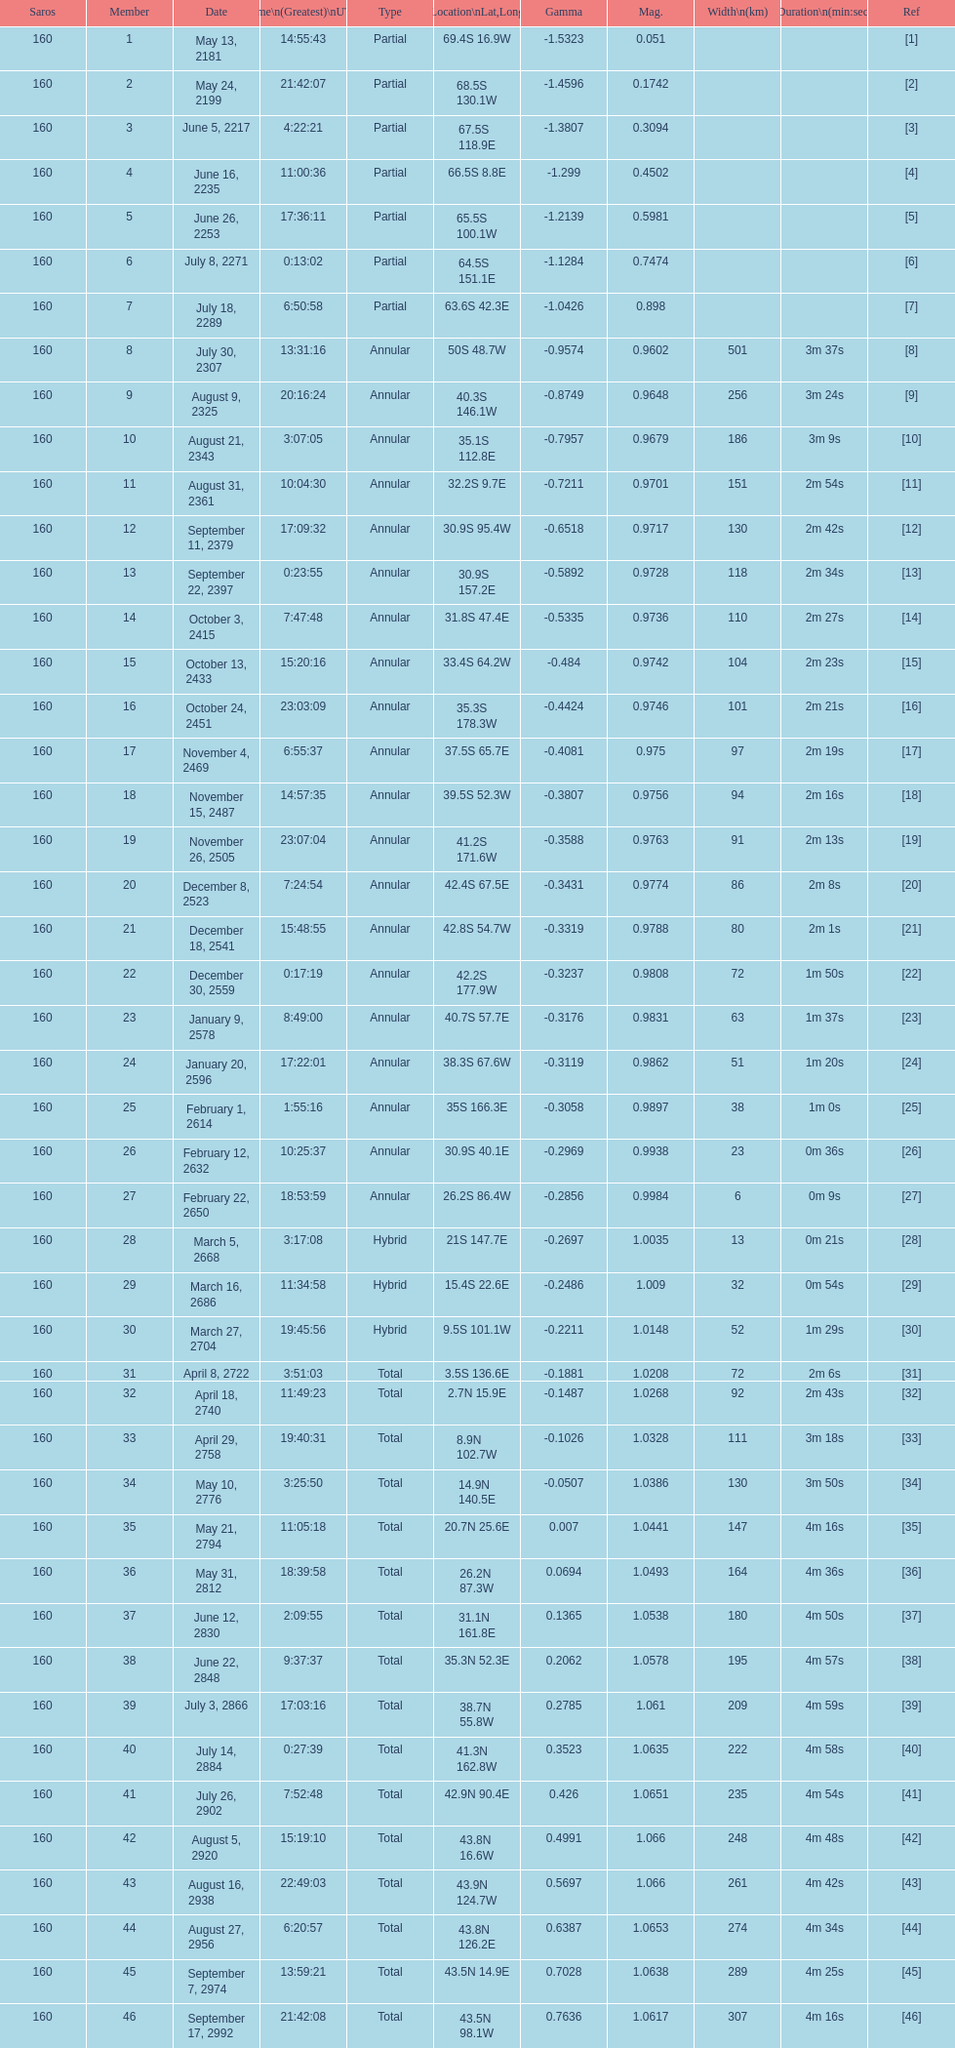What is the difference in magnitude between the may 13, 2181 solar saros and the may 24, 2199 solar saros? 0.1232. 